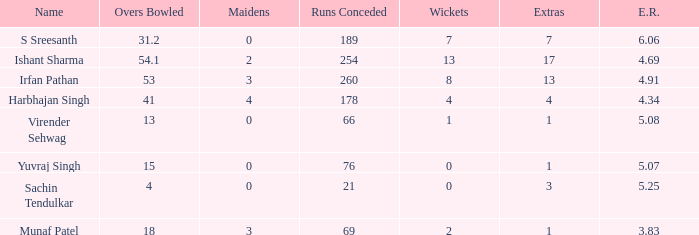Who are the maidens that have bowled exactly 13 overs? 0.0. 